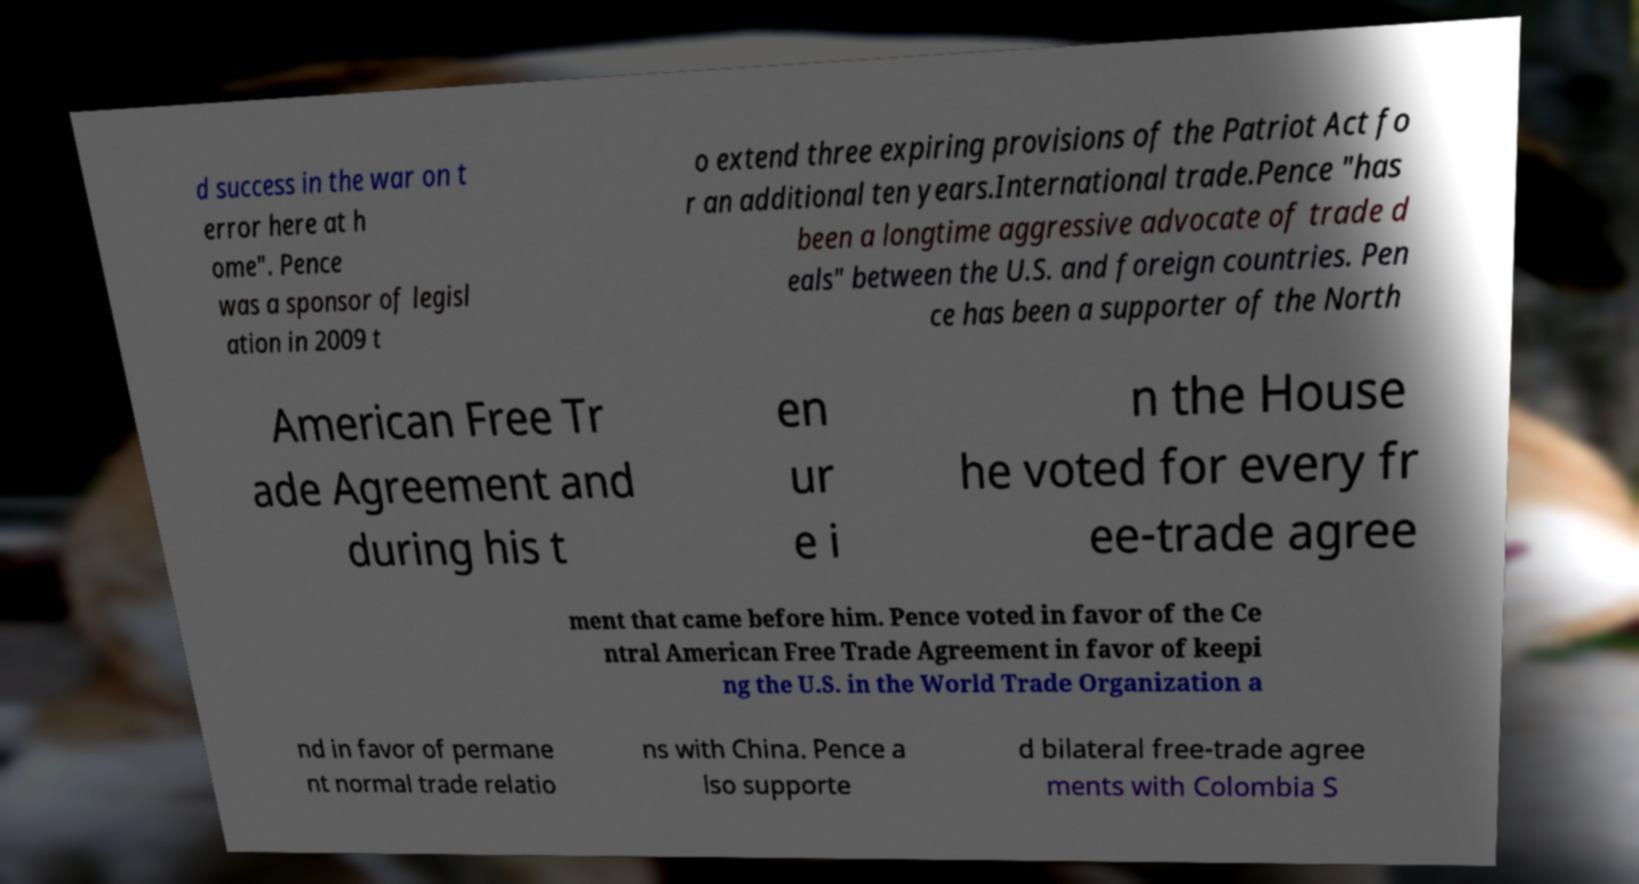Can you accurately transcribe the text from the provided image for me? d success in the war on t error here at h ome". Pence was a sponsor of legisl ation in 2009 t o extend three expiring provisions of the Patriot Act fo r an additional ten years.International trade.Pence "has been a longtime aggressive advocate of trade d eals" between the U.S. and foreign countries. Pen ce has been a supporter of the North American Free Tr ade Agreement and during his t en ur e i n the House he voted for every fr ee-trade agree ment that came before him. Pence voted in favor of the Ce ntral American Free Trade Agreement in favor of keepi ng the U.S. in the World Trade Organization a nd in favor of permane nt normal trade relatio ns with China. Pence a lso supporte d bilateral free-trade agree ments with Colombia S 